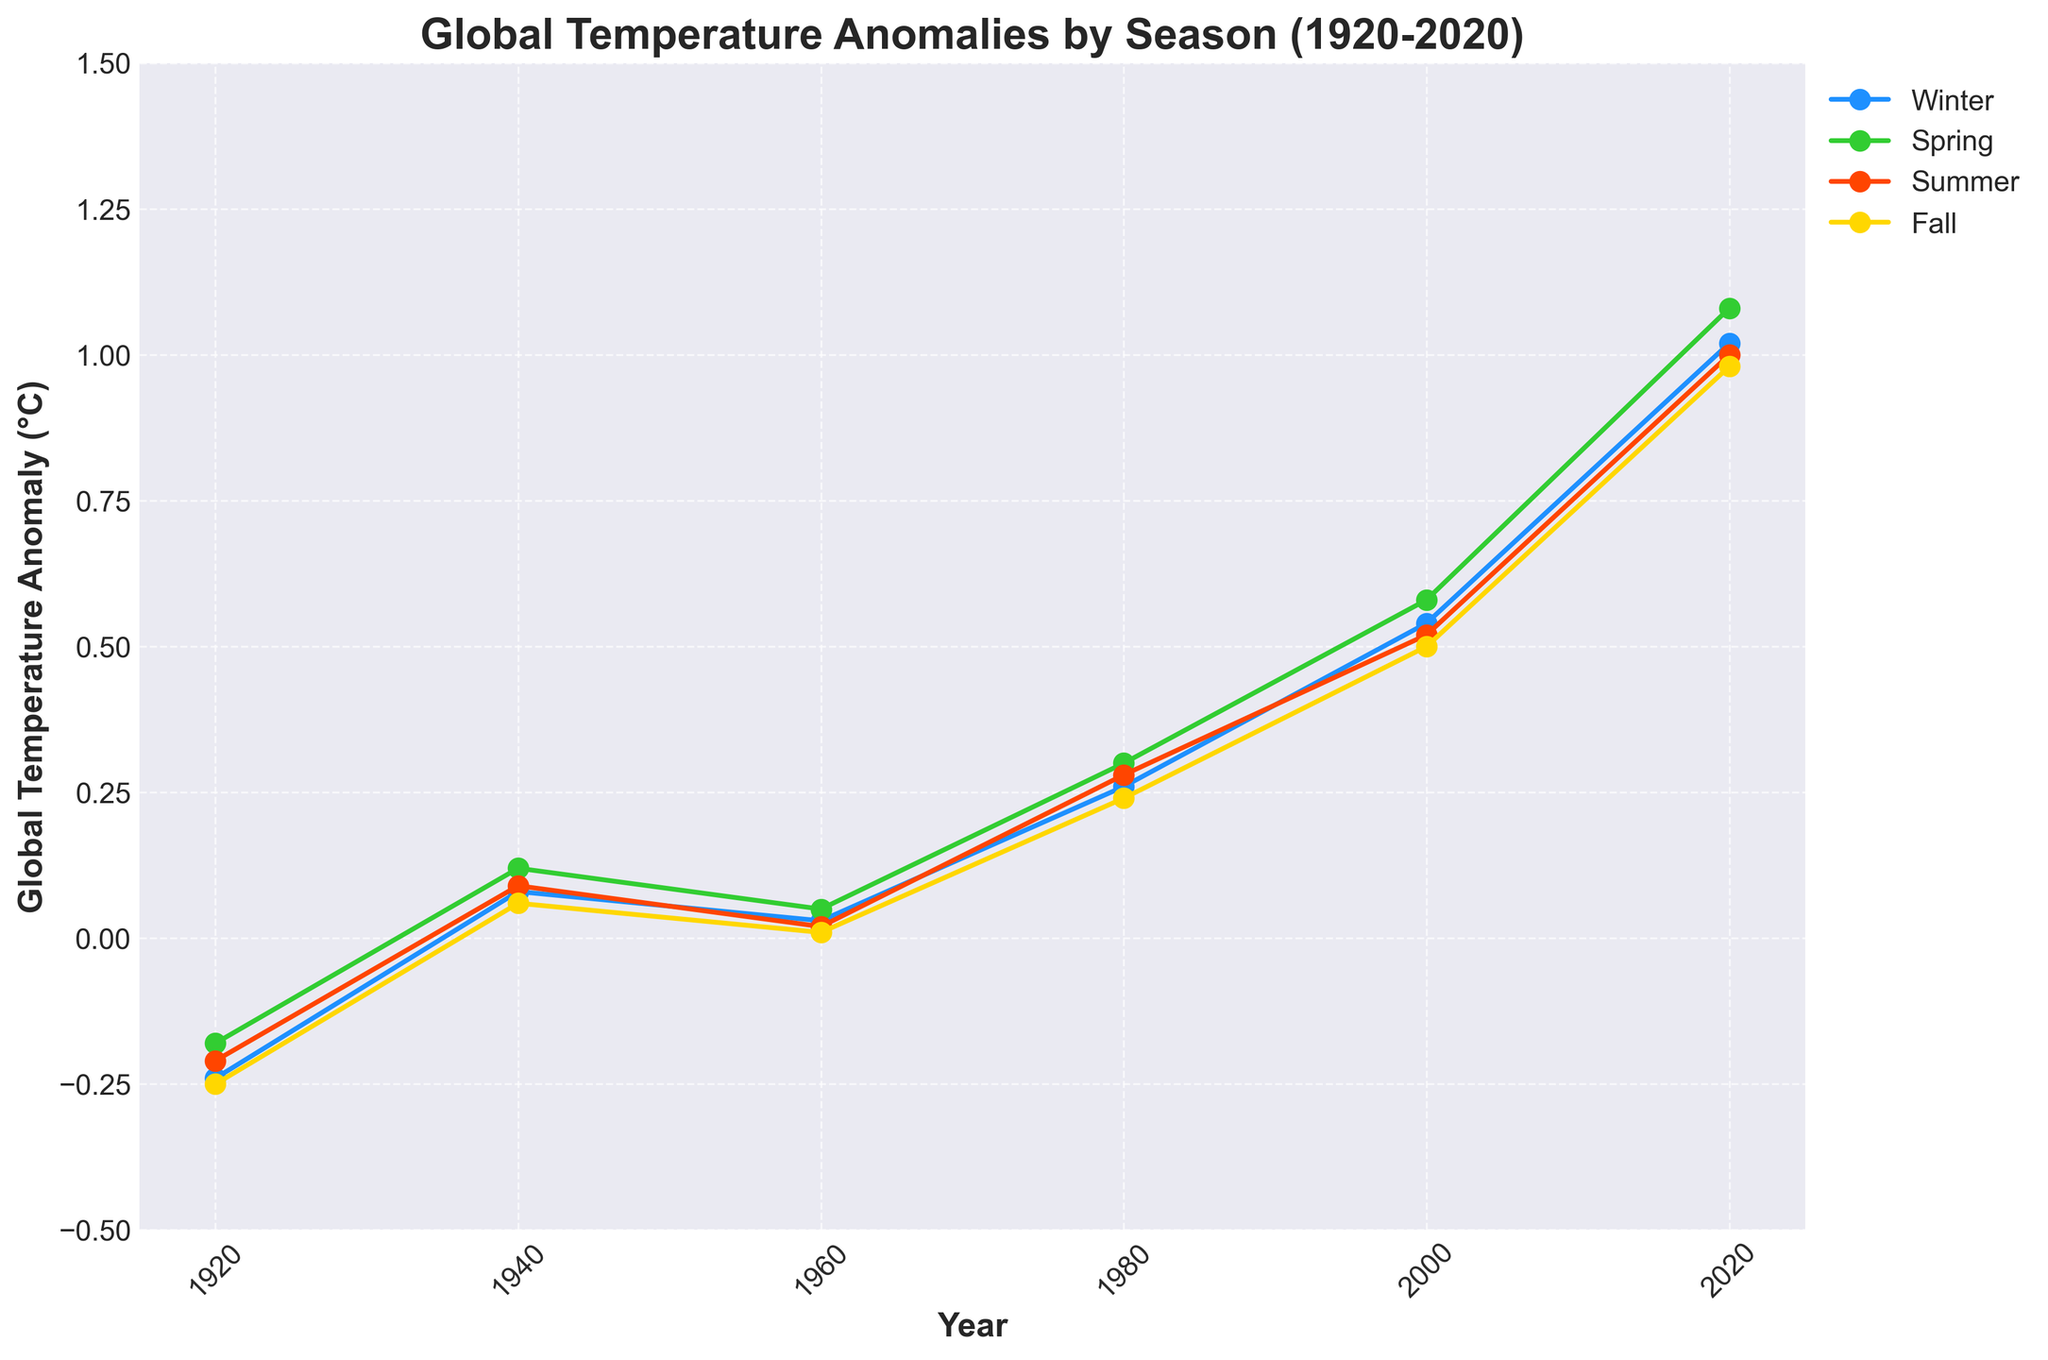What is the overall trend in global temperature anomalies from 1920 to 2020? The figure shows that each seasonal line shows a clear upward trend over time, indicating that global temperature anomalies have been increasing from 1920 to 2020.
Answer: Increasing Which season had the highest global temperature anomaly in 2020? The point representing Winter in 2020 is the highest among all the seasonal points plotted for that year.
Answer: Winter By how much did the global temperature anomaly increase in Winter from 1920 to 2020? The global temperature anomaly for Winter in 1920 is approximately -0.24°C and it is approximately 1.02°C in 2020, so the increase is 1.02 - (-0.24) = 1.26°C.
Answer: 1.26°C Which season shows the least variation in global temperature anomalies over the century? By visually inspecting the range of each seasonal line, Fall has the slightest variation in values, indicating the least variation in global temperature anomalies over the century.
Answer: Fall Which year showed approximately the same global temperature anomaly for all seasons? In 1960, the anomalies for Winter, Spring, Summer, and Fall are all clustered around similar values, approximately ranging from 0.01°C to 0.05°C.
Answer: 1960 What is the average global temperature anomaly across all seasons in 2000? In 2000, the temperature anomalies are Winter: 0.54°C, Spring: 0.58°C, Summer: 0.52°C, and Fall: 0.50°C. The average is (0.54 + 0.58 + 0.52 + 0.50) / 4 = 0.535°C.
Answer: 0.535°C Which season experienced the smallest increase in global temperature anomalies from 1940 to 2020? While Winter, Spring, Summer, and Fall all show increases from 1940 to 2020, Fall had the smallest increase, going from 0.06°C to 0.98°C, an increase of 0.92°C.
Answer: Fall What is the difference in global temperature anomalies between Summer in 1920 and Spring in 1980? The Summer anomaly in 1920 is about -0.21°C, and the Spring anomaly in 1980 is about 0.30°C. The difference is 0.30°C - (-0.21°C) = 0.51°C.
Answer: 0.51°C Which season in 1980 had the highest anomaly, and how does it compare to the highest anomaly in 2000? In 1980, Spring had the highest anomaly of 0.30°C. In 2000, Spring also had the highest anomaly of 0.58°C. Comparing these, 0.58°C - 0.30°C = 0.28°C.
Answer: Spring, 0.28°C 